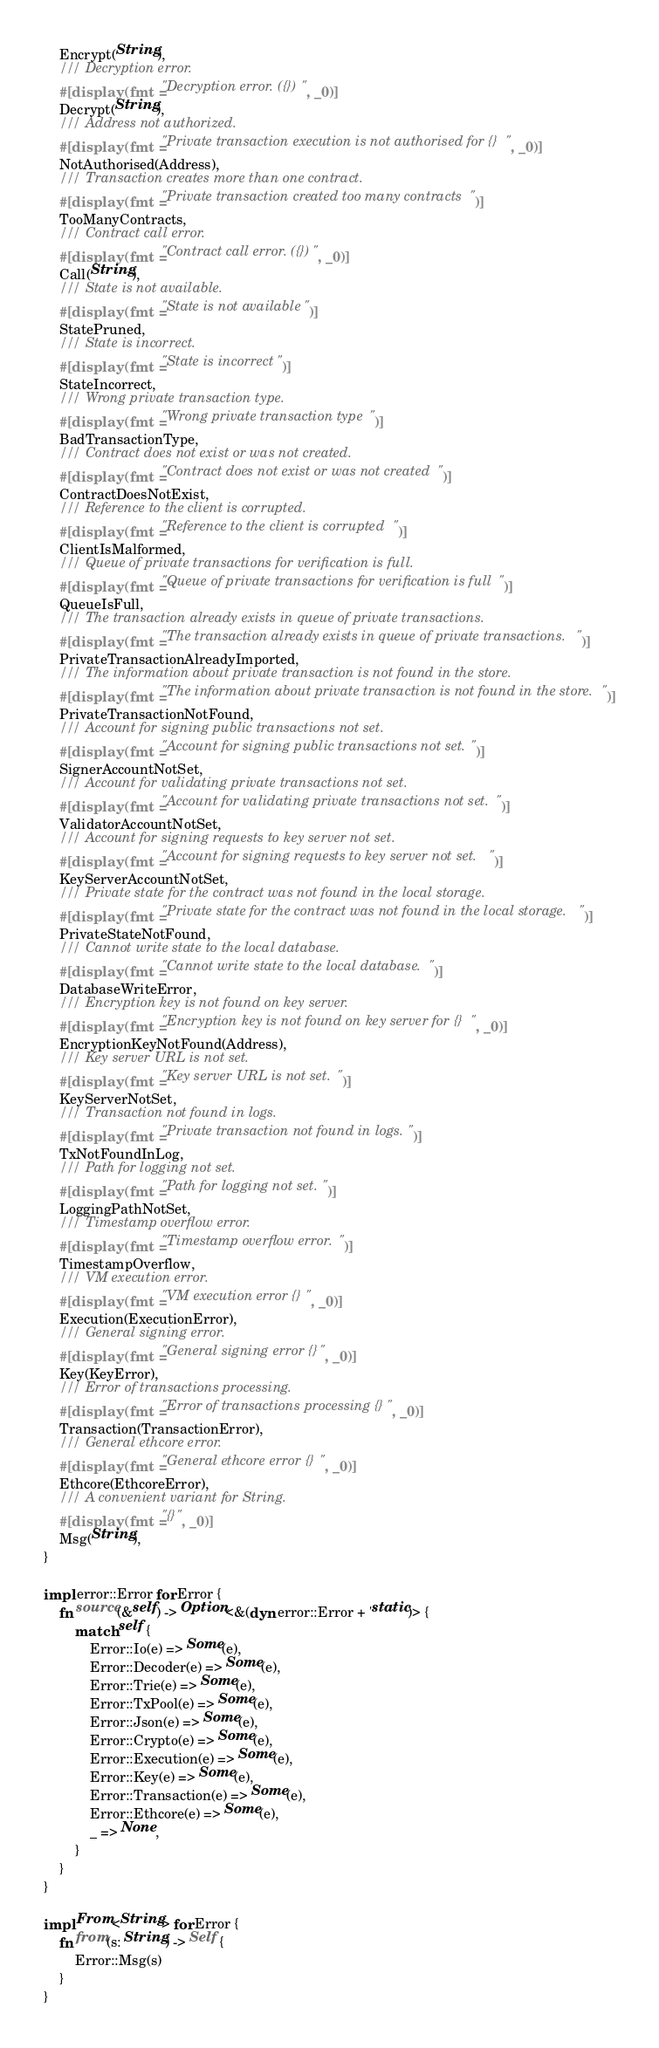<code> <loc_0><loc_0><loc_500><loc_500><_Rust_>	Encrypt(String),
	/// Decryption error.
	#[display(fmt = "Decryption error. ({})", _0)]
	Decrypt(String),
	/// Address not authorized.
	#[display(fmt = "Private transaction execution is not authorised for {}", _0)]
	NotAuthorised(Address),
	/// Transaction creates more than one contract.
	#[display(fmt = "Private transaction created too many contracts")]
	TooManyContracts,
	/// Contract call error.
	#[display(fmt = "Contract call error. ({})", _0)]
	Call(String),
	/// State is not available.
	#[display(fmt = "State is not available")]
	StatePruned,
	/// State is incorrect.
	#[display(fmt = "State is incorrect")]
	StateIncorrect,
	/// Wrong private transaction type.
	#[display(fmt = "Wrong private transaction type")]
	BadTransactionType,
	/// Contract does not exist or was not created.
	#[display(fmt = "Contract does not exist or was not created")]
	ContractDoesNotExist,
	/// Reference to the client is corrupted.
	#[display(fmt = "Reference to the client is corrupted")]
	ClientIsMalformed,
	/// Queue of private transactions for verification is full.
	#[display(fmt = "Queue of private transactions for verification is full")]
	QueueIsFull,
	/// The transaction already exists in queue of private transactions.
	#[display(fmt = "The transaction already exists in queue of private transactions.")]
	PrivateTransactionAlreadyImported,
	/// The information about private transaction is not found in the store.
	#[display(fmt = "The information about private transaction is not found in the store.")]
	PrivateTransactionNotFound,
	/// Account for signing public transactions not set.
	#[display(fmt = "Account for signing public transactions not set.")]
	SignerAccountNotSet,
	/// Account for validating private transactions not set.
	#[display(fmt = "Account for validating private transactions not set.")]
	ValidatorAccountNotSet,
	/// Account for signing requests to key server not set.
	#[display(fmt = "Account for signing requests to key server not set.")]
	KeyServerAccountNotSet,
	/// Private state for the contract was not found in the local storage.
	#[display(fmt = "Private state for the contract was not found in the local storage.")]
	PrivateStateNotFound,
	/// Cannot write state to the local database.
	#[display(fmt = "Cannot write state to the local database.")]
	DatabaseWriteError,
	/// Encryption key is not found on key server.
	#[display(fmt = "Encryption key is not found on key server for {}", _0)]
	EncryptionKeyNotFound(Address),
	/// Key server URL is not set.
	#[display(fmt = "Key server URL is not set.")]
	KeyServerNotSet,
	/// Transaction not found in logs.
	#[display(fmt = "Private transaction not found in logs.")]
	TxNotFoundInLog,
	/// Path for logging not set.
	#[display(fmt = "Path for logging not set.")]
	LoggingPathNotSet,
	/// Timestamp overflow error.
	#[display(fmt = "Timestamp overflow error.")]
	TimestampOverflow,
	/// VM execution error.
	#[display(fmt = "VM execution error {}", _0)]
	Execution(ExecutionError),
	/// General signing error.
	#[display(fmt = "General signing error {}", _0)]
	Key(KeyError),
	/// Error of transactions processing.
	#[display(fmt = "Error of transactions processing {}", _0)]
	Transaction(TransactionError),
	/// General ethcore error.
	#[display(fmt = "General ethcore error {}", _0)]
	Ethcore(EthcoreError),
	/// A convenient variant for String.
	#[display(fmt = "{}", _0)]
	Msg(String),
}

impl error::Error for Error {
	fn source(&self) -> Option<&(dyn error::Error + 'static)> {
		match self {
			Error::Io(e) => Some(e),
			Error::Decoder(e) => Some(e),
			Error::Trie(e) => Some(e),
			Error::TxPool(e) => Some(e),
			Error::Json(e) => Some(e),
			Error::Crypto(e) => Some(e),
			Error::Execution(e) => Some(e),
			Error::Key(e) => Some(e),
			Error::Transaction(e) => Some(e),
			Error::Ethcore(e) => Some(e),
			_ => None,
		}
	}
}

impl From<String> for Error {
	fn from(s: String) -> Self {
		Error::Msg(s)
	}
}
</code> 